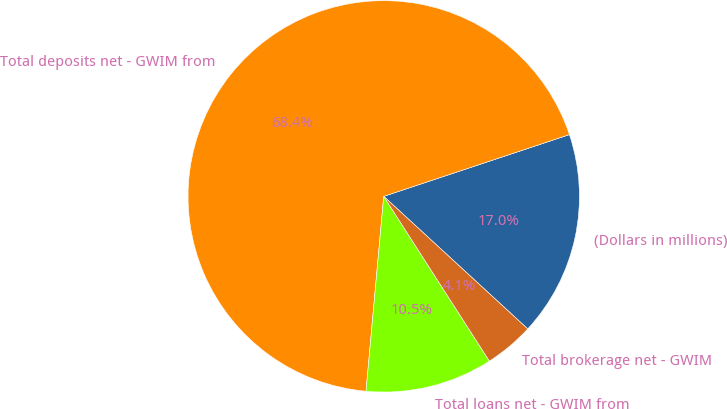Convert chart to OTSL. <chart><loc_0><loc_0><loc_500><loc_500><pie_chart><fcel>(Dollars in millions)<fcel>Total deposits net - GWIM from<fcel>Total loans net - GWIM from<fcel>Total brokerage net - GWIM<nl><fcel>16.95%<fcel>68.44%<fcel>10.52%<fcel>4.08%<nl></chart> 